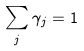Convert formula to latex. <formula><loc_0><loc_0><loc_500><loc_500>\sum _ { j } \gamma _ { j } = 1</formula> 